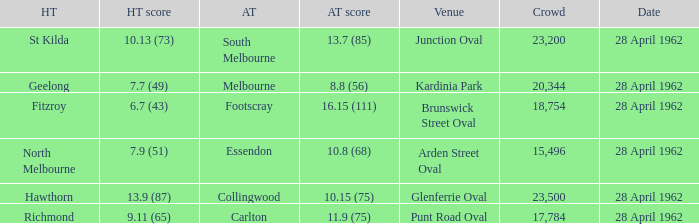Which visiting team competed at brunswick street oval? Footscray. 